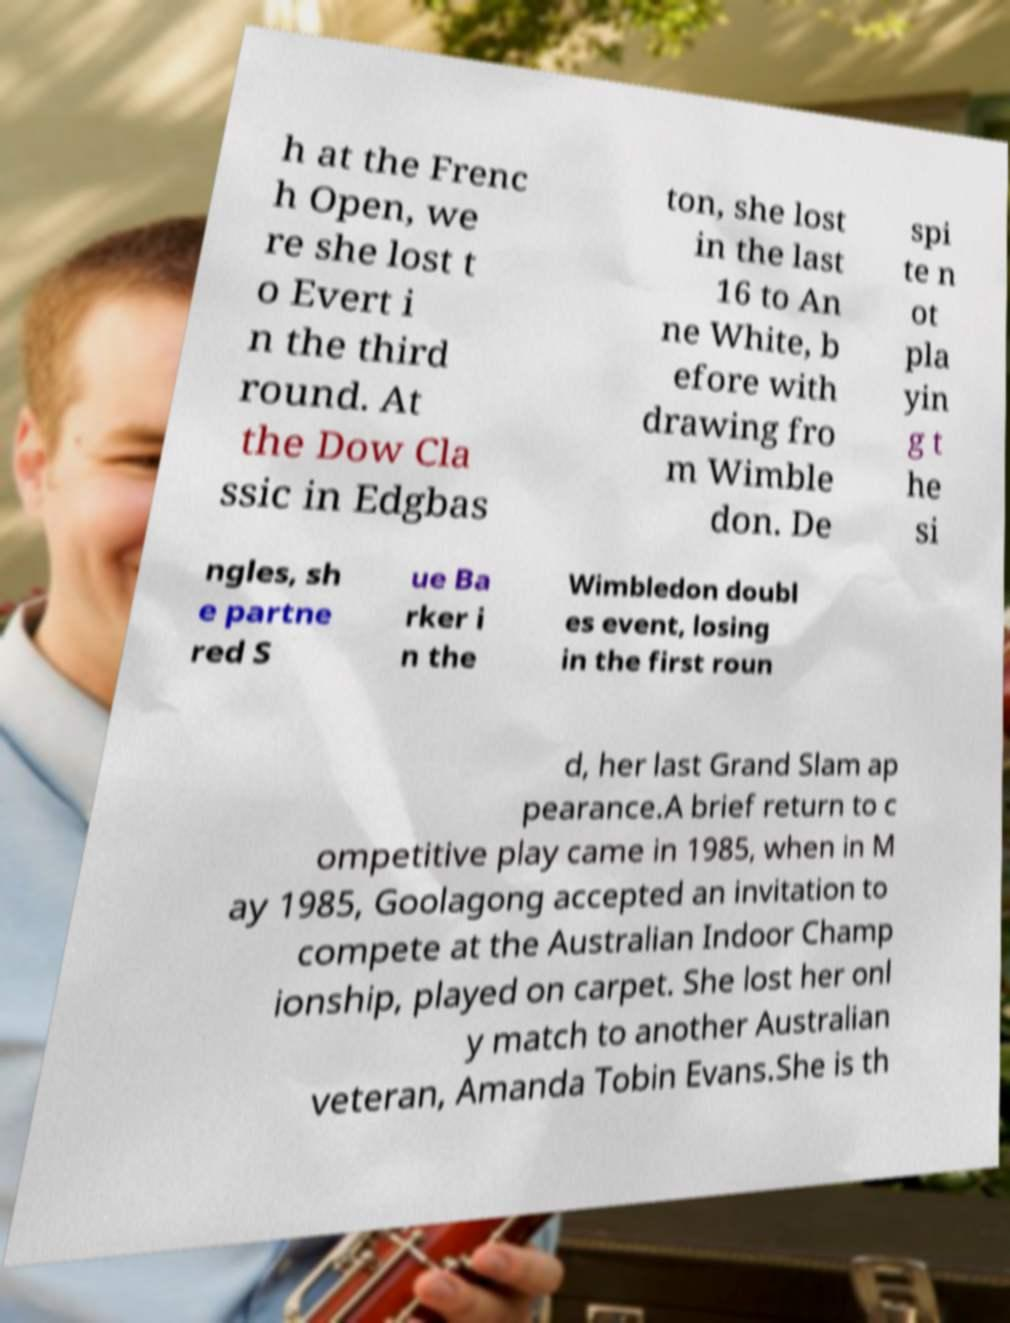There's text embedded in this image that I need extracted. Can you transcribe it verbatim? h at the Frenc h Open, we re she lost t o Evert i n the third round. At the Dow Cla ssic in Edgbas ton, she lost in the last 16 to An ne White, b efore with drawing fro m Wimble don. De spi te n ot pla yin g t he si ngles, sh e partne red S ue Ba rker i n the Wimbledon doubl es event, losing in the first roun d, her last Grand Slam ap pearance.A brief return to c ompetitive play came in 1985, when in M ay 1985, Goolagong accepted an invitation to compete at the Australian Indoor Champ ionship, played on carpet. She lost her onl y match to another Australian veteran, Amanda Tobin Evans.She is th 